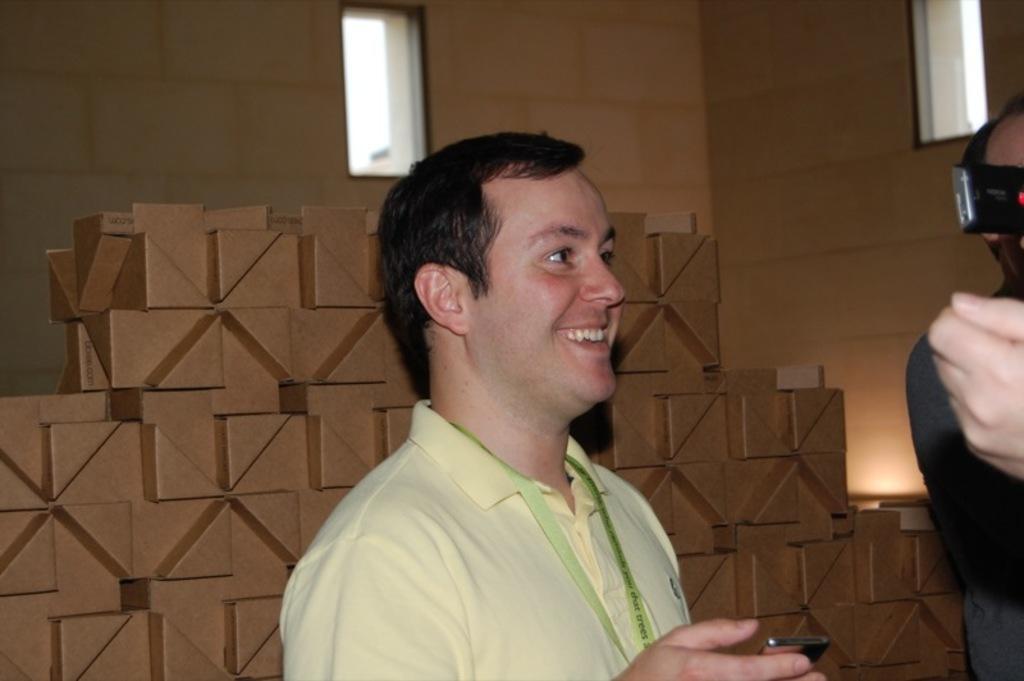Can you describe this image briefly? There are people standing and this man smiling and holding a mobile. Background we can see wall and windows. 